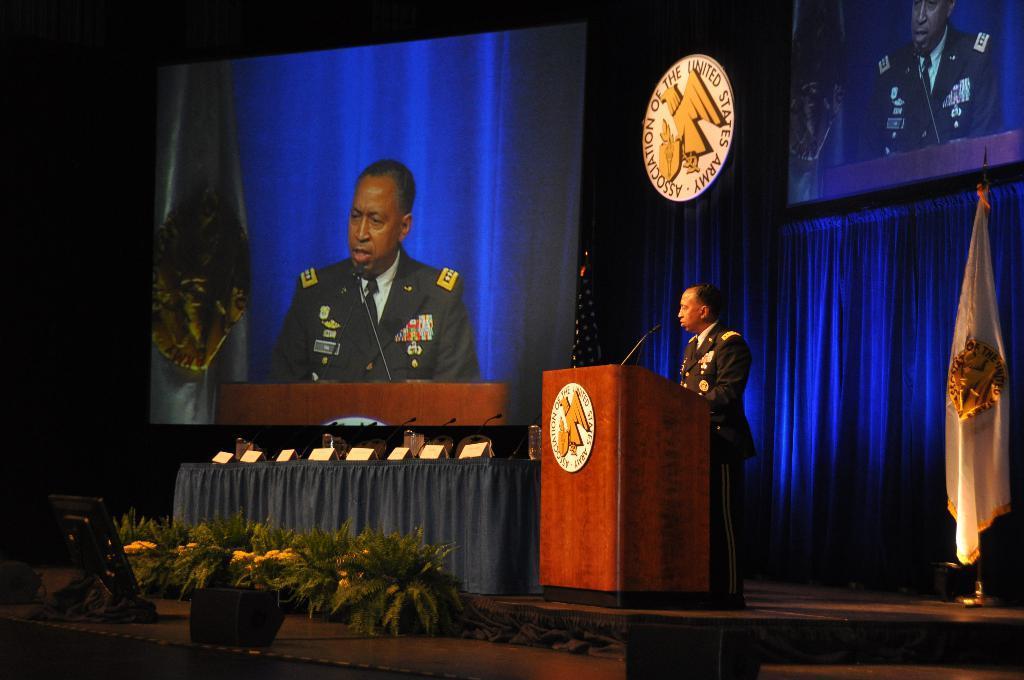Describe this image in one or two sentences. In this image we can see the screen. And we can see a person standing at the podium. And we can see the microphone. And we can see the curtain. And we can see some decorative items on the stage. 